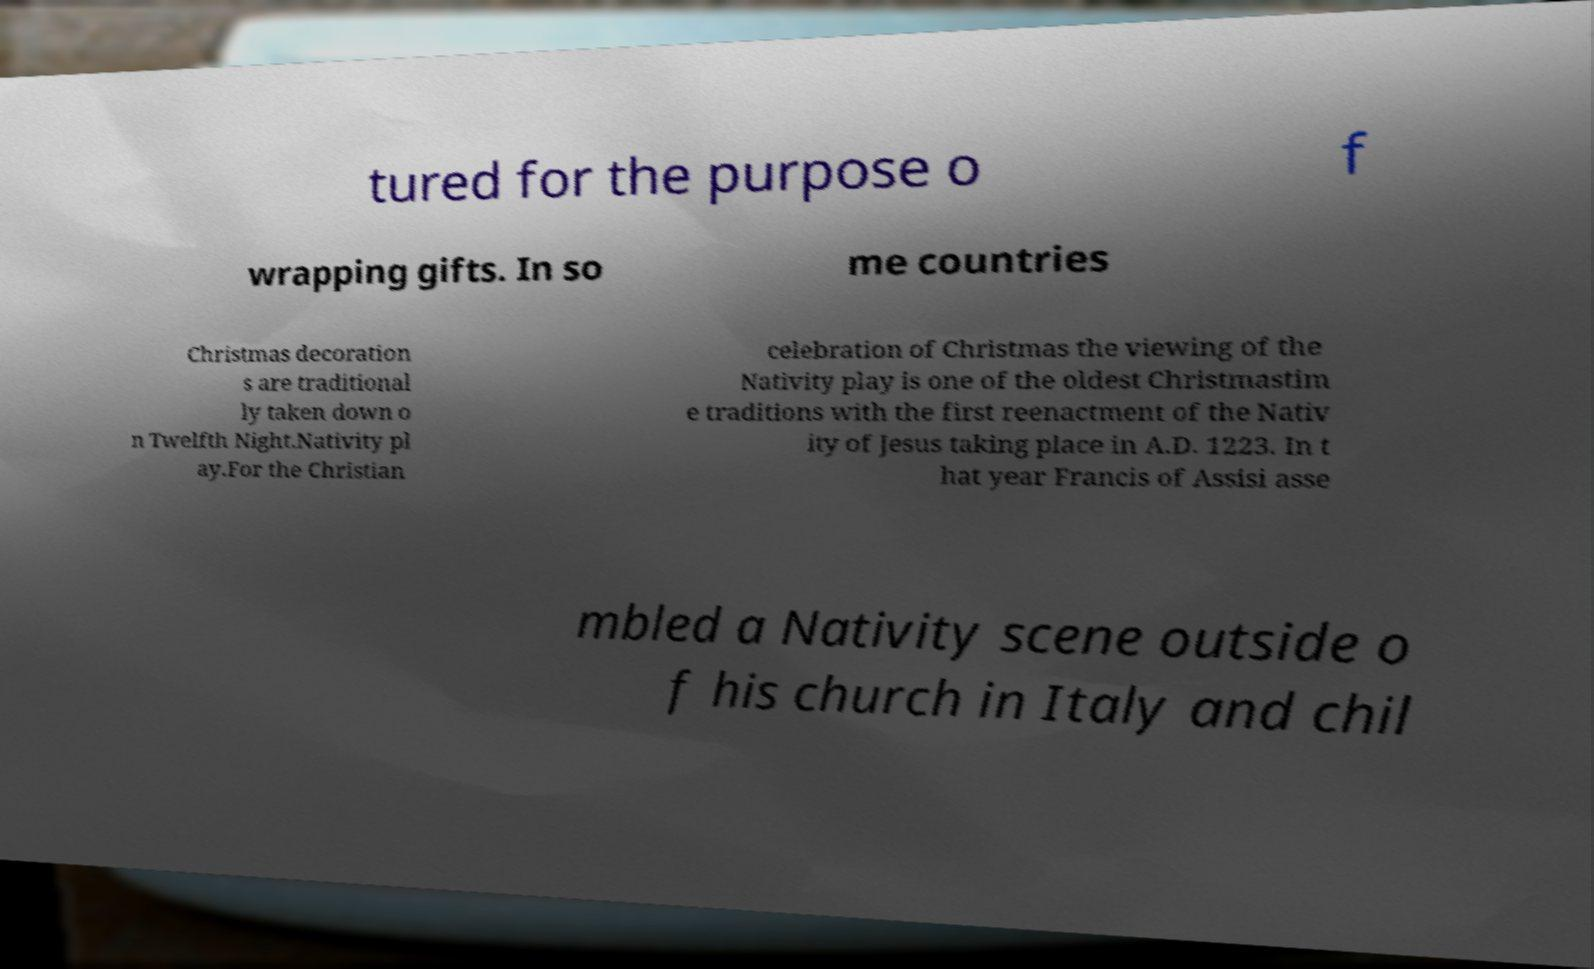Please identify and transcribe the text found in this image. tured for the purpose o f wrapping gifts. In so me countries Christmas decoration s are traditional ly taken down o n Twelfth Night.Nativity pl ay.For the Christian celebration of Christmas the viewing of the Nativity play is one of the oldest Christmastim e traditions with the first reenactment of the Nativ ity of Jesus taking place in A.D. 1223. In t hat year Francis of Assisi asse mbled a Nativity scene outside o f his church in Italy and chil 